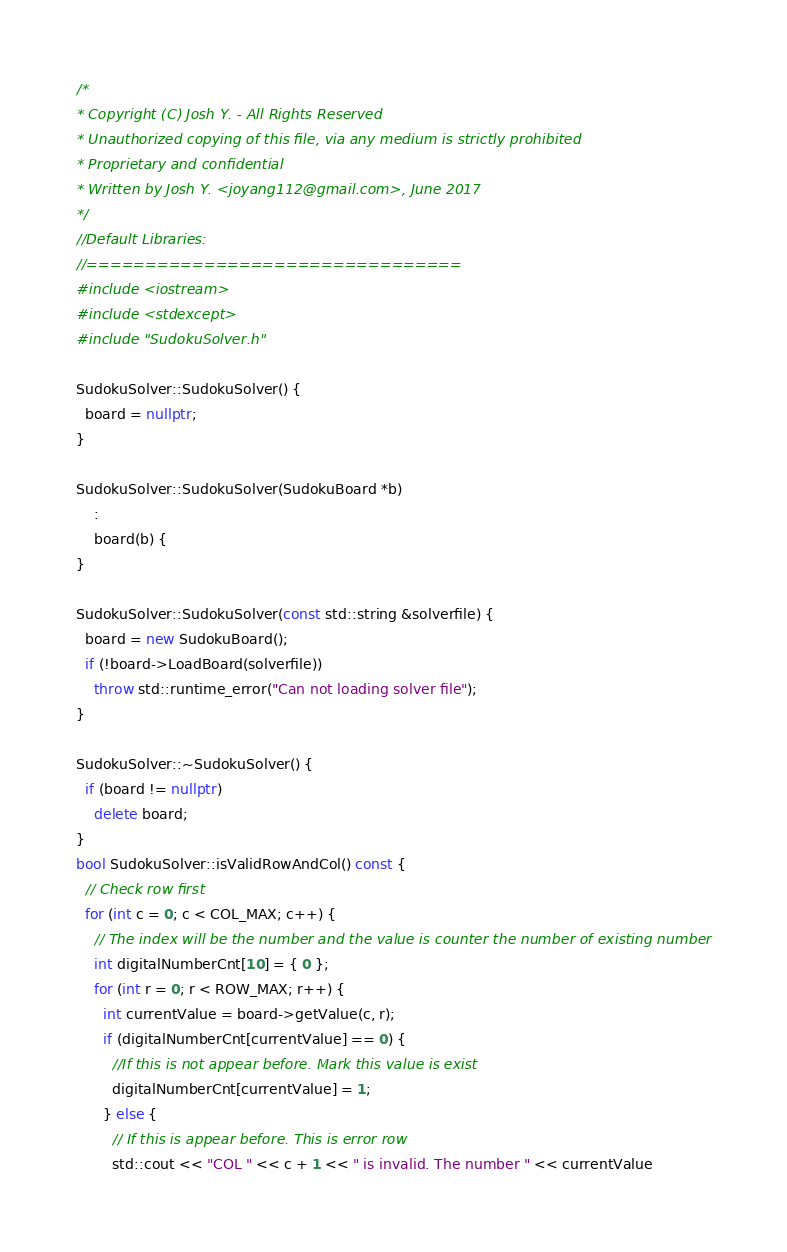Convert code to text. <code><loc_0><loc_0><loc_500><loc_500><_C++_>/*
* Copyright (C) Josh Y. - All Rights Reserved
* Unauthorized copying of this file, via any medium is strictly prohibited 
* Proprietary and confidential
* Written by Josh Y. <joyang112@gmail.com>, June 2017
*/
//Default Libraries:
//================================
#include <iostream>
#include <stdexcept>
#include "SudokuSolver.h"

SudokuSolver::SudokuSolver() {
  board = nullptr;
}

SudokuSolver::SudokuSolver(SudokuBoard *b)
    :
    board(b) {
}

SudokuSolver::SudokuSolver(const std::string &solverfile) {
  board = new SudokuBoard();
  if (!board->LoadBoard(solverfile))
    throw std::runtime_error("Can not loading solver file");
}

SudokuSolver::~SudokuSolver() {
  if (board != nullptr)
    delete board;
}
bool SudokuSolver::isValidRowAndCol() const {
  // Check row first
  for (int c = 0; c < COL_MAX; c++) {
    // The index will be the number and the value is counter the number of existing number
    int digitalNumberCnt[10] = { 0 };
    for (int r = 0; r < ROW_MAX; r++) {
      int currentValue = board->getValue(c, r);
      if (digitalNumberCnt[currentValue] == 0) {
        //If this is not appear before. Mark this value is exist
        digitalNumberCnt[currentValue] = 1;
      } else {
        // If this is appear before. This is error row
        std::cout << "COL " << c + 1 << " is invalid. The number " << currentValue</code> 